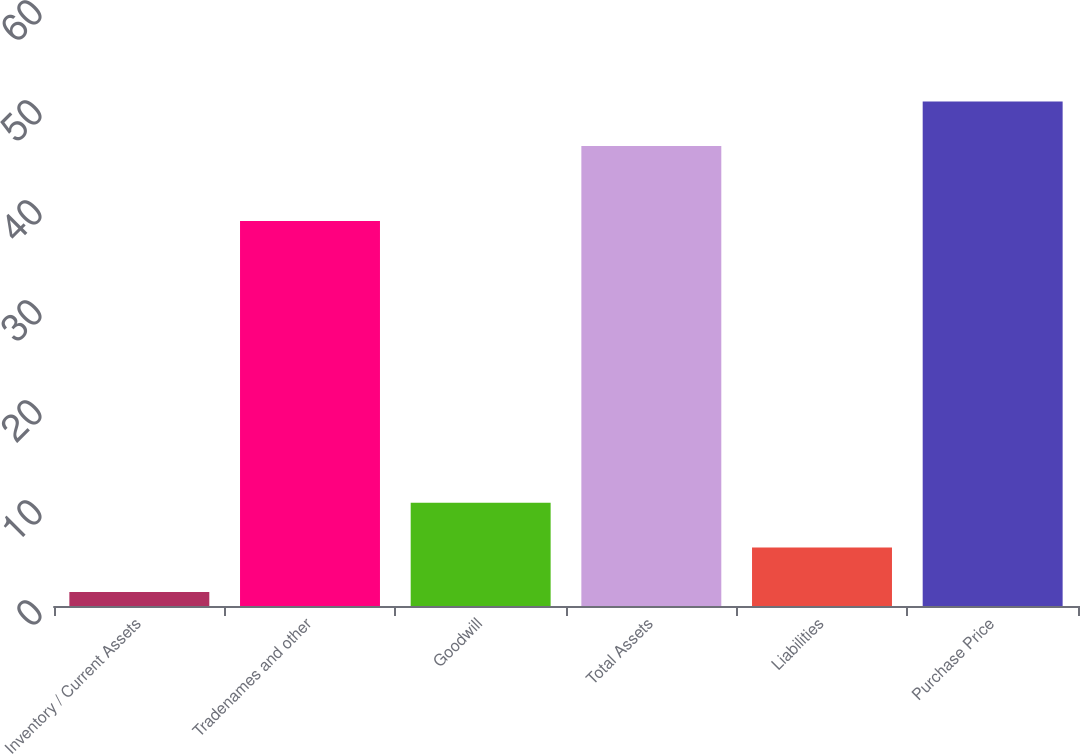Convert chart. <chart><loc_0><loc_0><loc_500><loc_500><bar_chart><fcel>Inventory / Current Assets<fcel>Tradenames and other<fcel>Goodwill<fcel>Total Assets<fcel>Liabilities<fcel>Purchase Price<nl><fcel>1.4<fcel>38.5<fcel>10.32<fcel>46<fcel>5.86<fcel>50.46<nl></chart> 